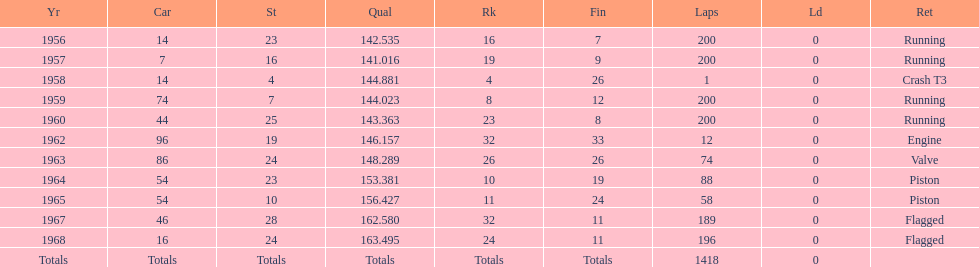How long did bob veith have the number 54 car at the indy 500? 2 years. 